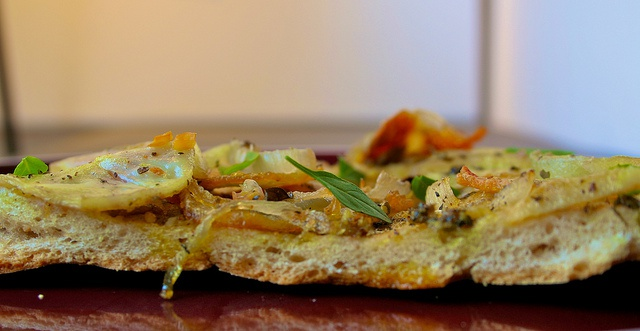Describe the objects in this image and their specific colors. I can see a pizza in tan and olive tones in this image. 